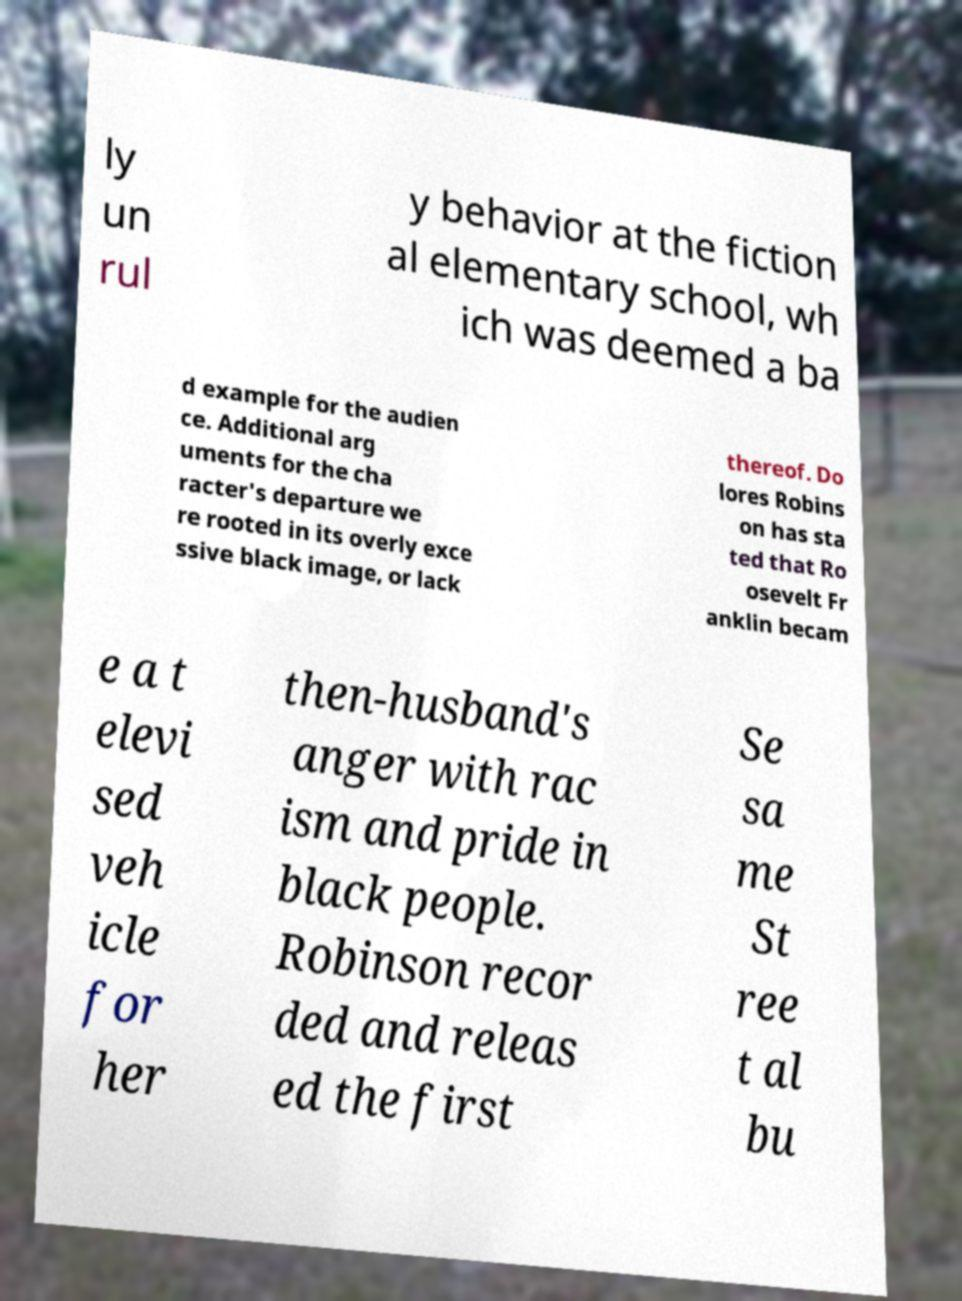Please read and relay the text visible in this image. What does it say? ly un rul y behavior at the fiction al elementary school, wh ich was deemed a ba d example for the audien ce. Additional arg uments for the cha racter's departure we re rooted in its overly exce ssive black image, or lack thereof. Do lores Robins on has sta ted that Ro osevelt Fr anklin becam e a t elevi sed veh icle for her then-husband's anger with rac ism and pride in black people. Robinson recor ded and releas ed the first Se sa me St ree t al bu 